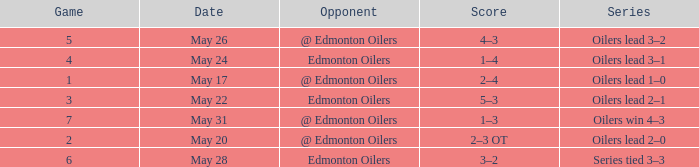Opponent of @ edmonton oilers, and a Game larger than 1, and a Series of oilers lead 3–2 had what score? 4–3. 